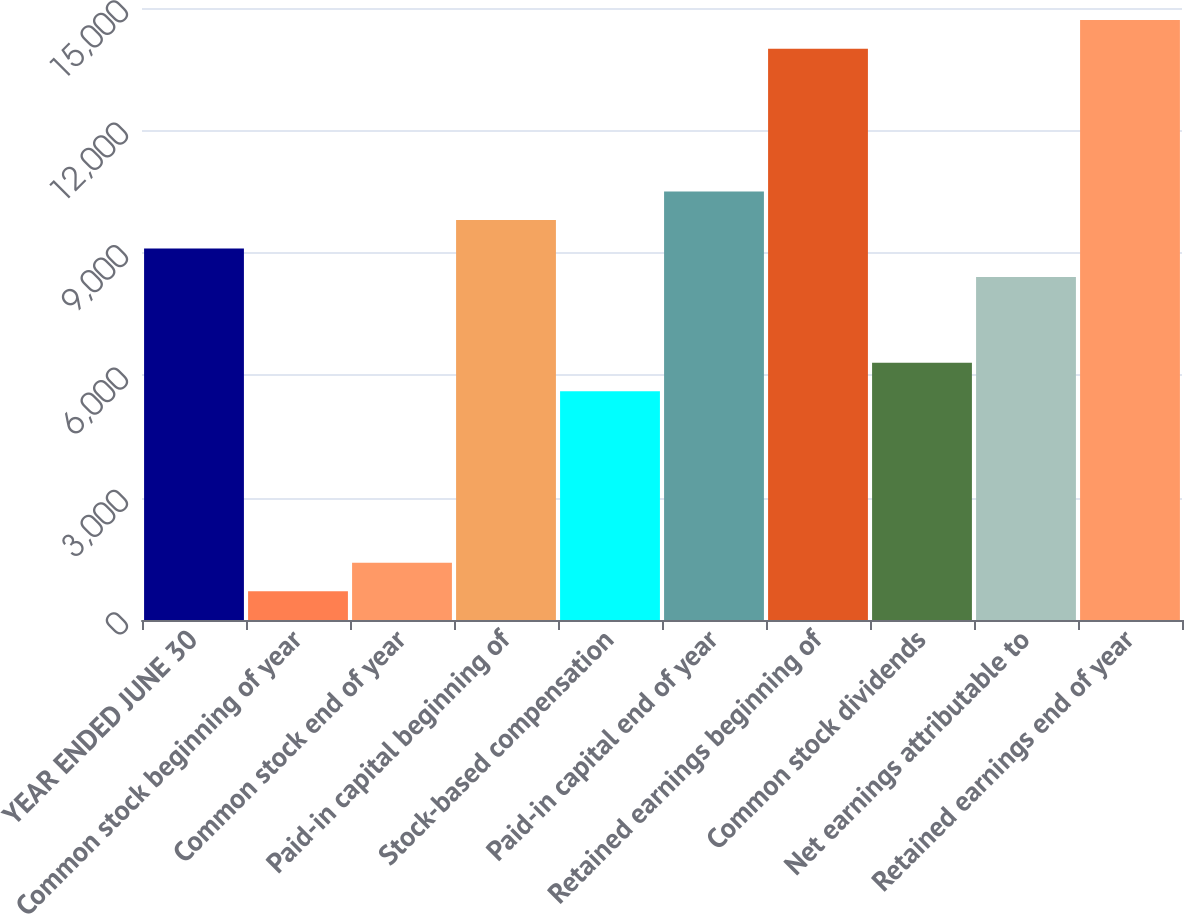Convert chart. <chart><loc_0><loc_0><loc_500><loc_500><bar_chart><fcel>YEAR ENDED JUNE 30<fcel>Common stock beginning of year<fcel>Common stock end of year<fcel>Paid-in capital beginning of<fcel>Stock-based compensation<fcel>Paid-in capital end of year<fcel>Retained earnings beginning of<fcel>Common stock dividends<fcel>Net earnings attributable to<fcel>Retained earnings end of year<nl><fcel>9103.98<fcel>704.46<fcel>1404.42<fcel>9803.94<fcel>5604.18<fcel>10503.9<fcel>14003.7<fcel>6304.14<fcel>8404.02<fcel>14703.7<nl></chart> 